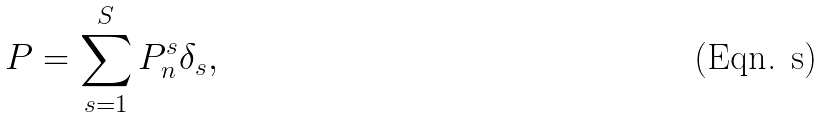Convert formula to latex. <formula><loc_0><loc_0><loc_500><loc_500>P = \sum _ { s = 1 } ^ { S } { P _ { n } ^ { s } } { \delta } _ { s } ,</formula> 